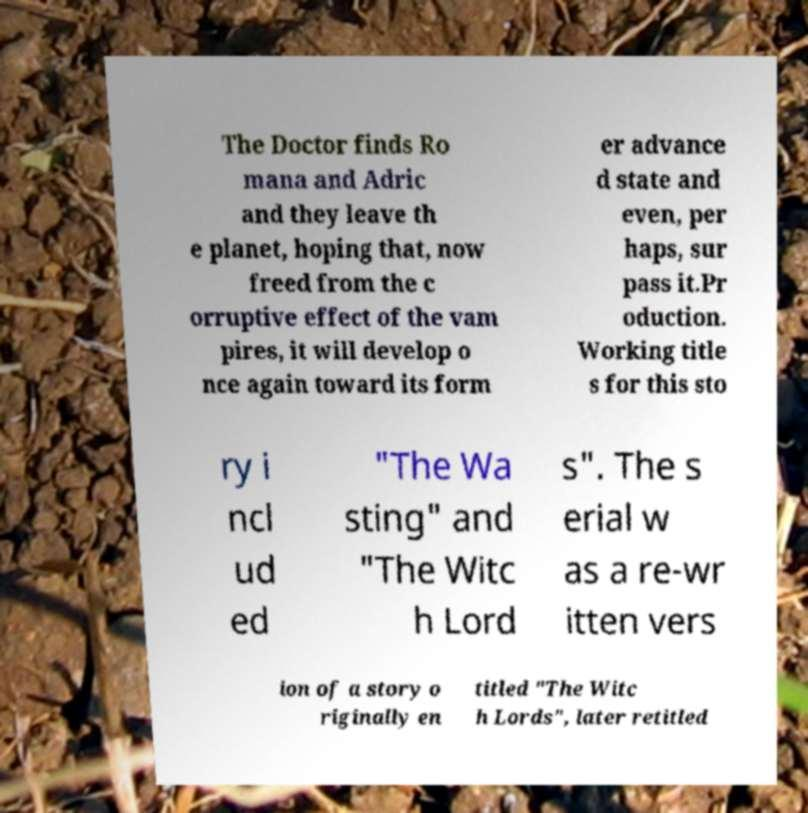For documentation purposes, I need the text within this image transcribed. Could you provide that? The Doctor finds Ro mana and Adric and they leave th e planet, hoping that, now freed from the c orruptive effect of the vam pires, it will develop o nce again toward its form er advance d state and even, per haps, sur pass it.Pr oduction. Working title s for this sto ry i ncl ud ed "The Wa sting" and "The Witc h Lord s". The s erial w as a re-wr itten vers ion of a story o riginally en titled "The Witc h Lords", later retitled 